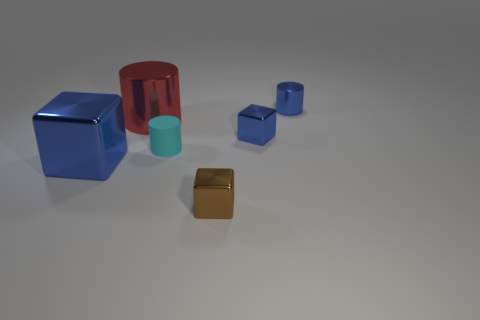How big is the brown thing?
Your answer should be very brief. Small. There is a cylinder that is the same size as the rubber object; what is its color?
Keep it short and to the point. Blue. Is there a metal cylinder that has the same color as the big metallic block?
Your answer should be very brief. Yes. What material is the cyan object?
Give a very brief answer. Rubber. How many small blue shiny cylinders are there?
Keep it short and to the point. 1. There is a big metallic block left of the small cyan thing; is its color the same as the small metallic object in front of the tiny blue cube?
Give a very brief answer. No. There is another block that is the same color as the big metal block; what is its size?
Your answer should be compact. Small. What number of other things are there of the same size as the red thing?
Your response must be concise. 1. The small shiny block behind the small cyan cylinder is what color?
Make the answer very short. Blue. Do the small cylinder that is in front of the blue cylinder and the large cube have the same material?
Your response must be concise. No. 